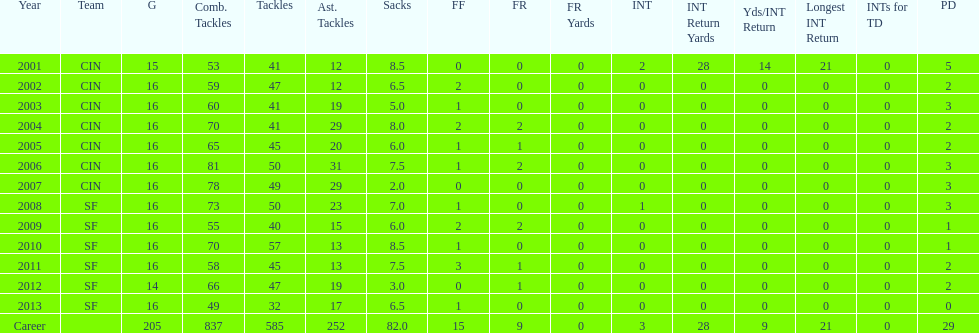How many consecutive years were there 20 or more assisted tackles? 5. 